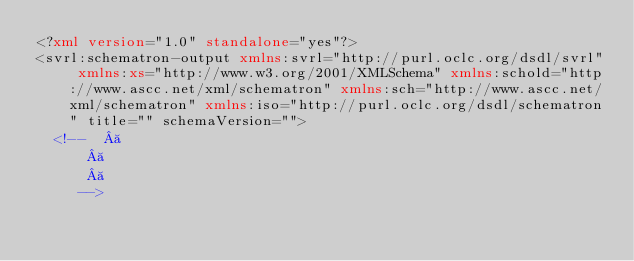Convert code to text. <code><loc_0><loc_0><loc_500><loc_500><_XML_><?xml version="1.0" standalone="yes"?>
<svrl:schematron-output xmlns:svrl="http://purl.oclc.org/dsdl/svrl" xmlns:xs="http://www.w3.org/2001/XMLSchema" xmlns:schold="http://www.ascc.net/xml/schematron" xmlns:sch="http://www.ascc.net/xml/schematron" xmlns:iso="http://purl.oclc.org/dsdl/schematron" title="" schemaVersion="">
  <!--   
		   
		   
		 --></code> 